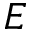Convert formula to latex. <formula><loc_0><loc_0><loc_500><loc_500>E</formula> 